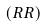<formula> <loc_0><loc_0><loc_500><loc_500>( R R )</formula> 